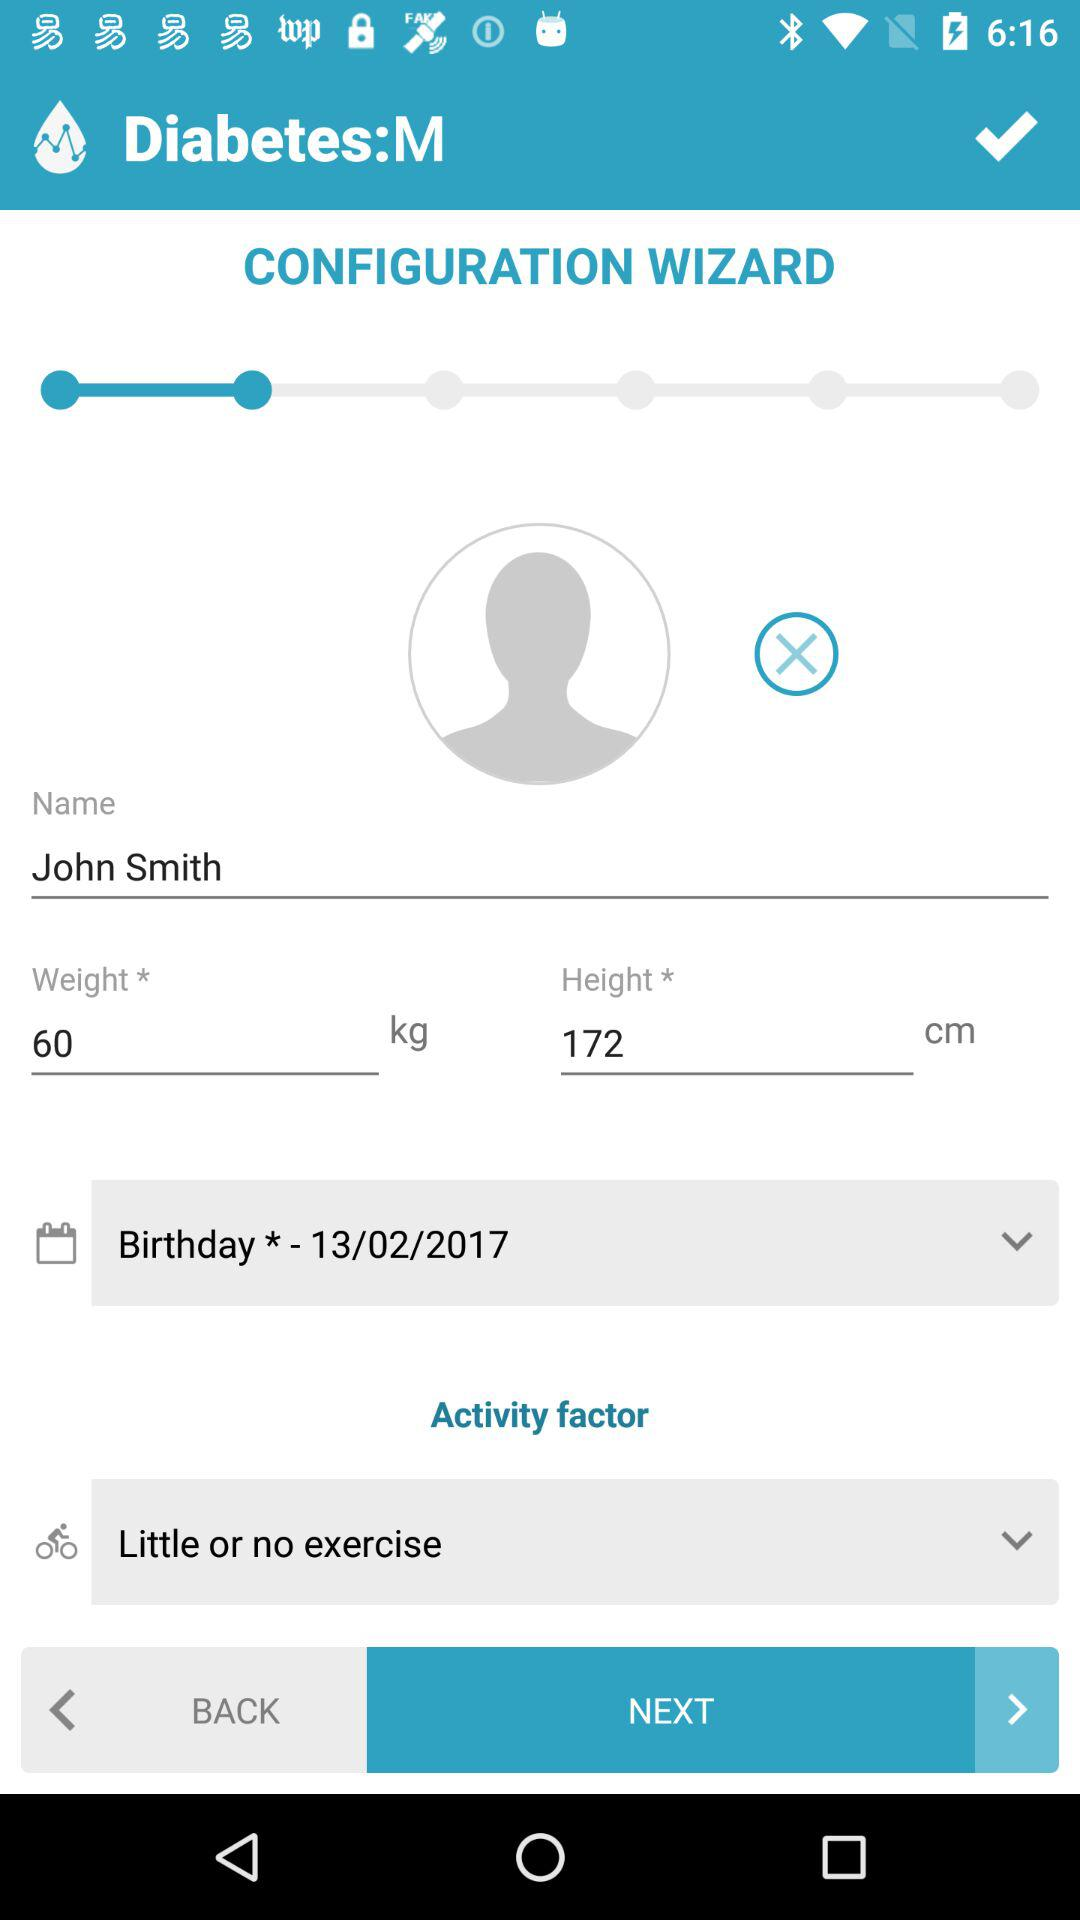What is the birth date? The birth date is February 13, 2017. 